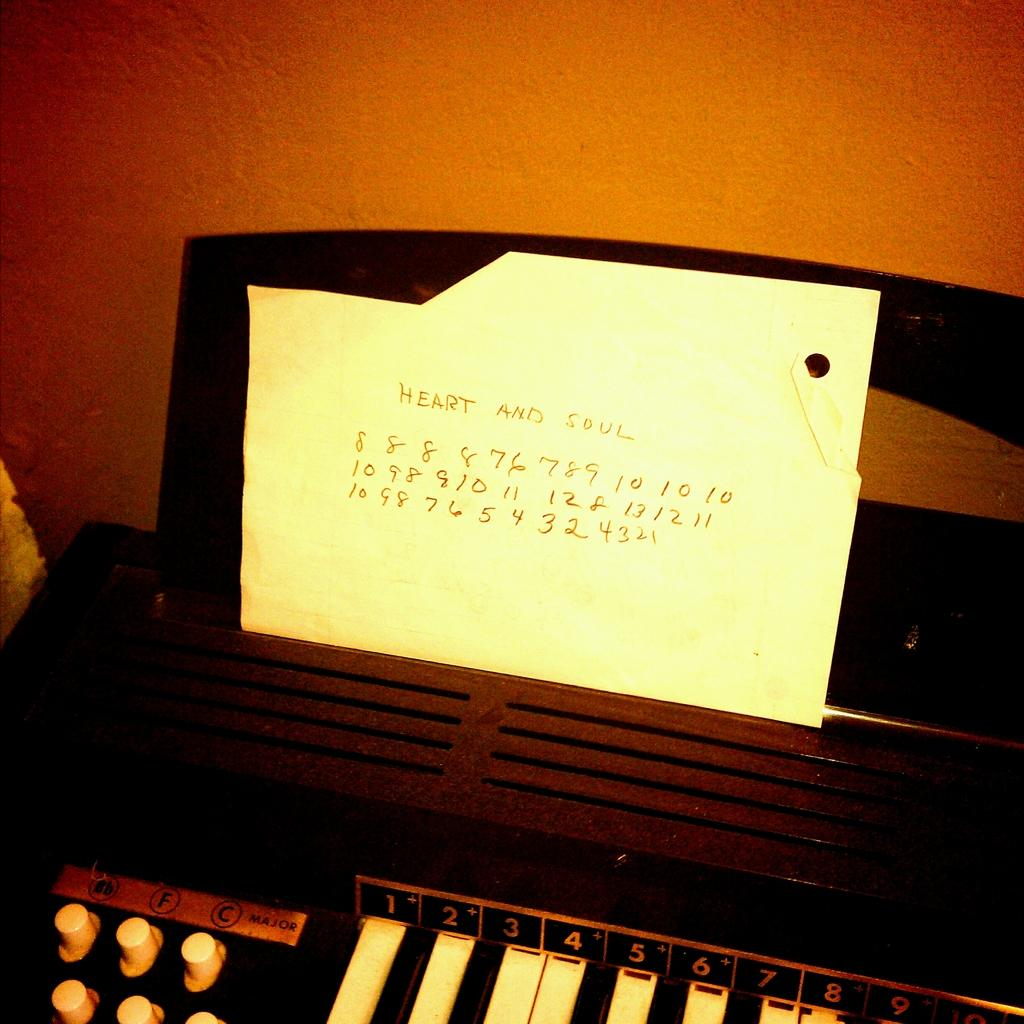What object in the image can be used to create music? There is a music instrument in the image. What is placed on the music instrument? There is a paper on the music instrument. What words can be read on the paper? The paper has the words "Heart and Soul" written on it. What color crayon is used to write the words "Heart and Soul" on the paper? There is no crayon mentioned or visible in the image; the words are written on the paper, but the writing instrument is not specified. 